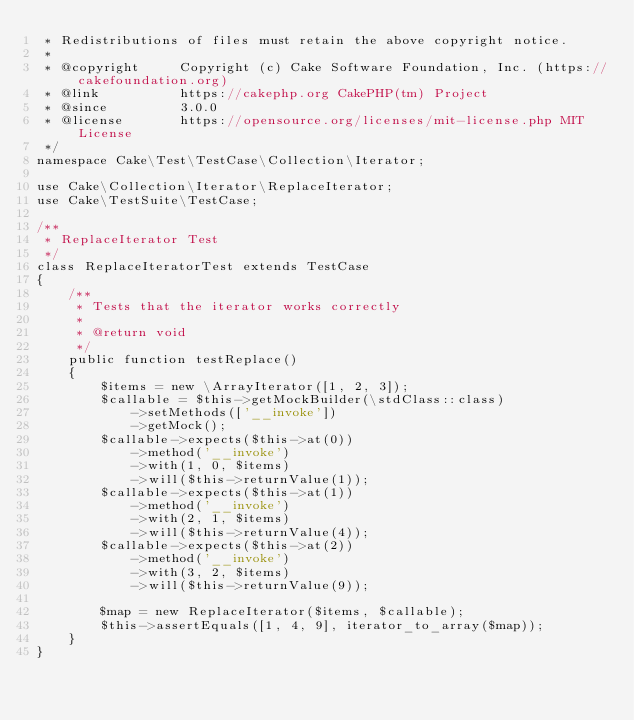<code> <loc_0><loc_0><loc_500><loc_500><_PHP_> * Redistributions of files must retain the above copyright notice.
 *
 * @copyright     Copyright (c) Cake Software Foundation, Inc. (https://cakefoundation.org)
 * @link          https://cakephp.org CakePHP(tm) Project
 * @since         3.0.0
 * @license       https://opensource.org/licenses/mit-license.php MIT License
 */
namespace Cake\Test\TestCase\Collection\Iterator;

use Cake\Collection\Iterator\ReplaceIterator;
use Cake\TestSuite\TestCase;

/**
 * ReplaceIterator Test
 */
class ReplaceIteratorTest extends TestCase
{
    /**
     * Tests that the iterator works correctly
     *
     * @return void
     */
    public function testReplace()
    {
        $items = new \ArrayIterator([1, 2, 3]);
        $callable = $this->getMockBuilder(\stdClass::class)
            ->setMethods(['__invoke'])
            ->getMock();
        $callable->expects($this->at(0))
            ->method('__invoke')
            ->with(1, 0, $items)
            ->will($this->returnValue(1));
        $callable->expects($this->at(1))
            ->method('__invoke')
            ->with(2, 1, $items)
            ->will($this->returnValue(4));
        $callable->expects($this->at(2))
            ->method('__invoke')
            ->with(3, 2, $items)
            ->will($this->returnValue(9));

        $map = new ReplaceIterator($items, $callable);
        $this->assertEquals([1, 4, 9], iterator_to_array($map));
    }
}
</code> 